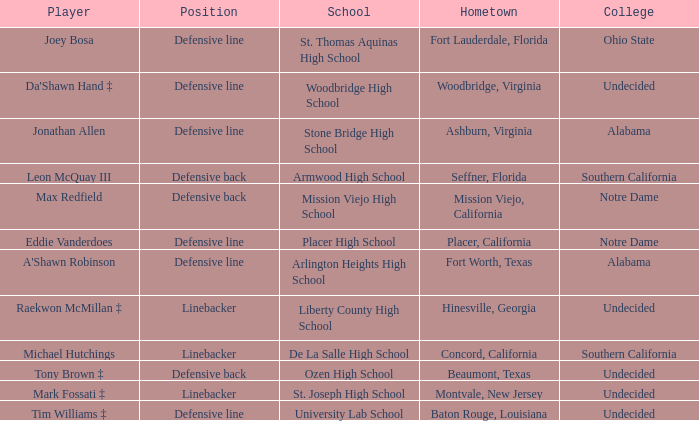What is the position of the player from Fort Lauderdale, Florida? Defensive line. 